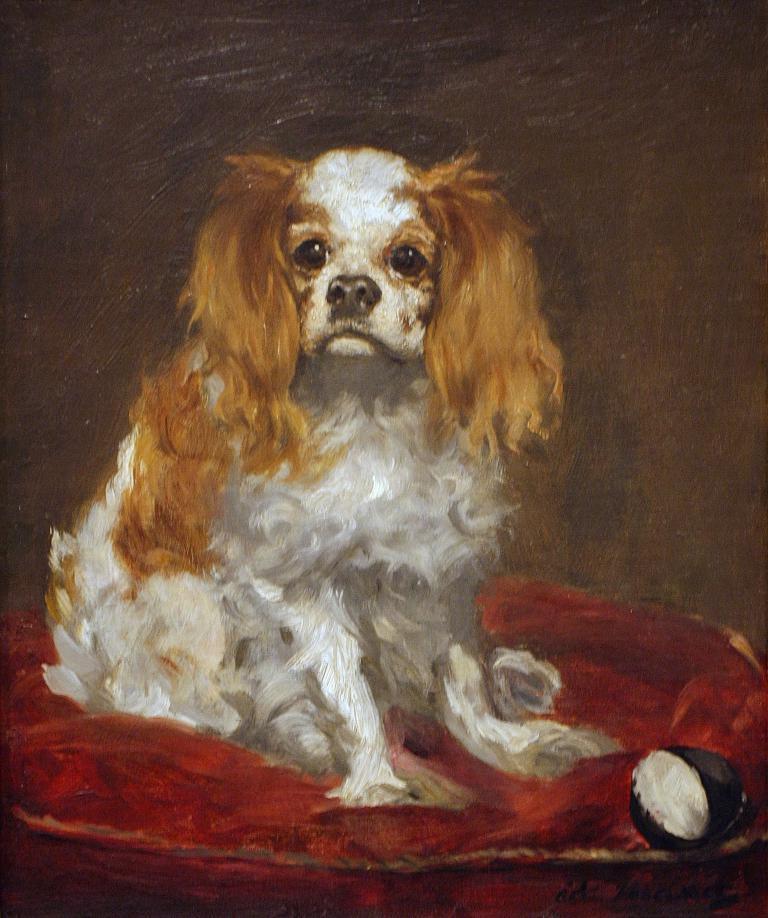How would you summarize this image in a sentence or two? In this image, we can see a painting of a dog which is in brown and white color. 